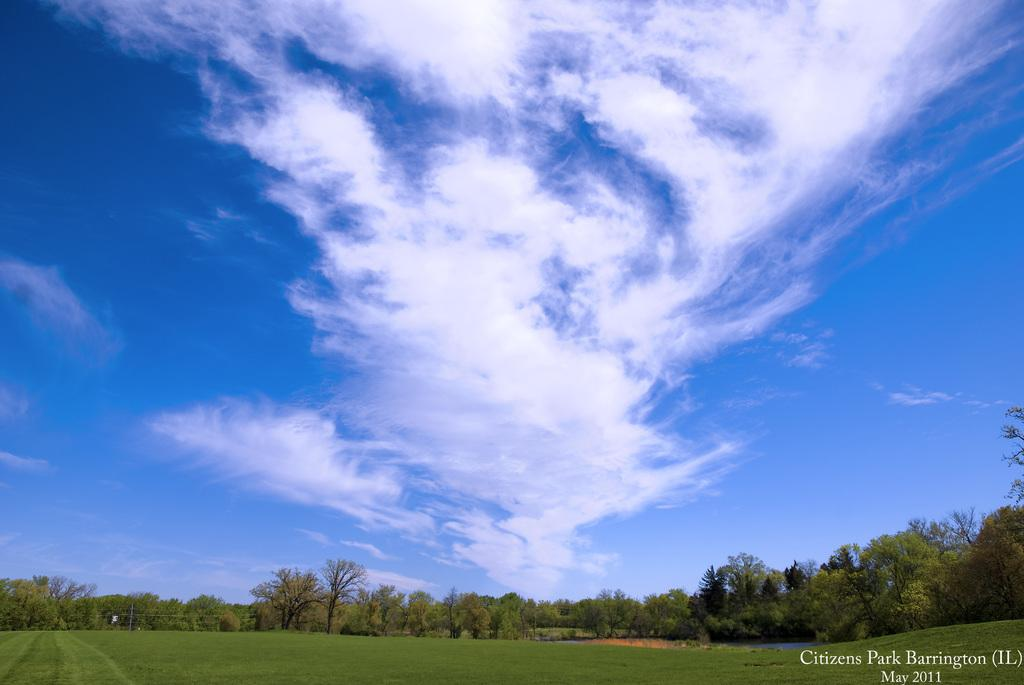What type of vegetation is present in the image? There are many trees in the image. What is the color of the grass on the ground? The grass on the ground is green. What can be seen in the sky in the image? There are clouds in the sky. Where is the text located in the image? The text is at the bottom right of the image. Are there any boats visible in the image? No, there are no boats present in the image. Can you see any cattle grazing in the grass? No, there are no cattle visible in the image. 